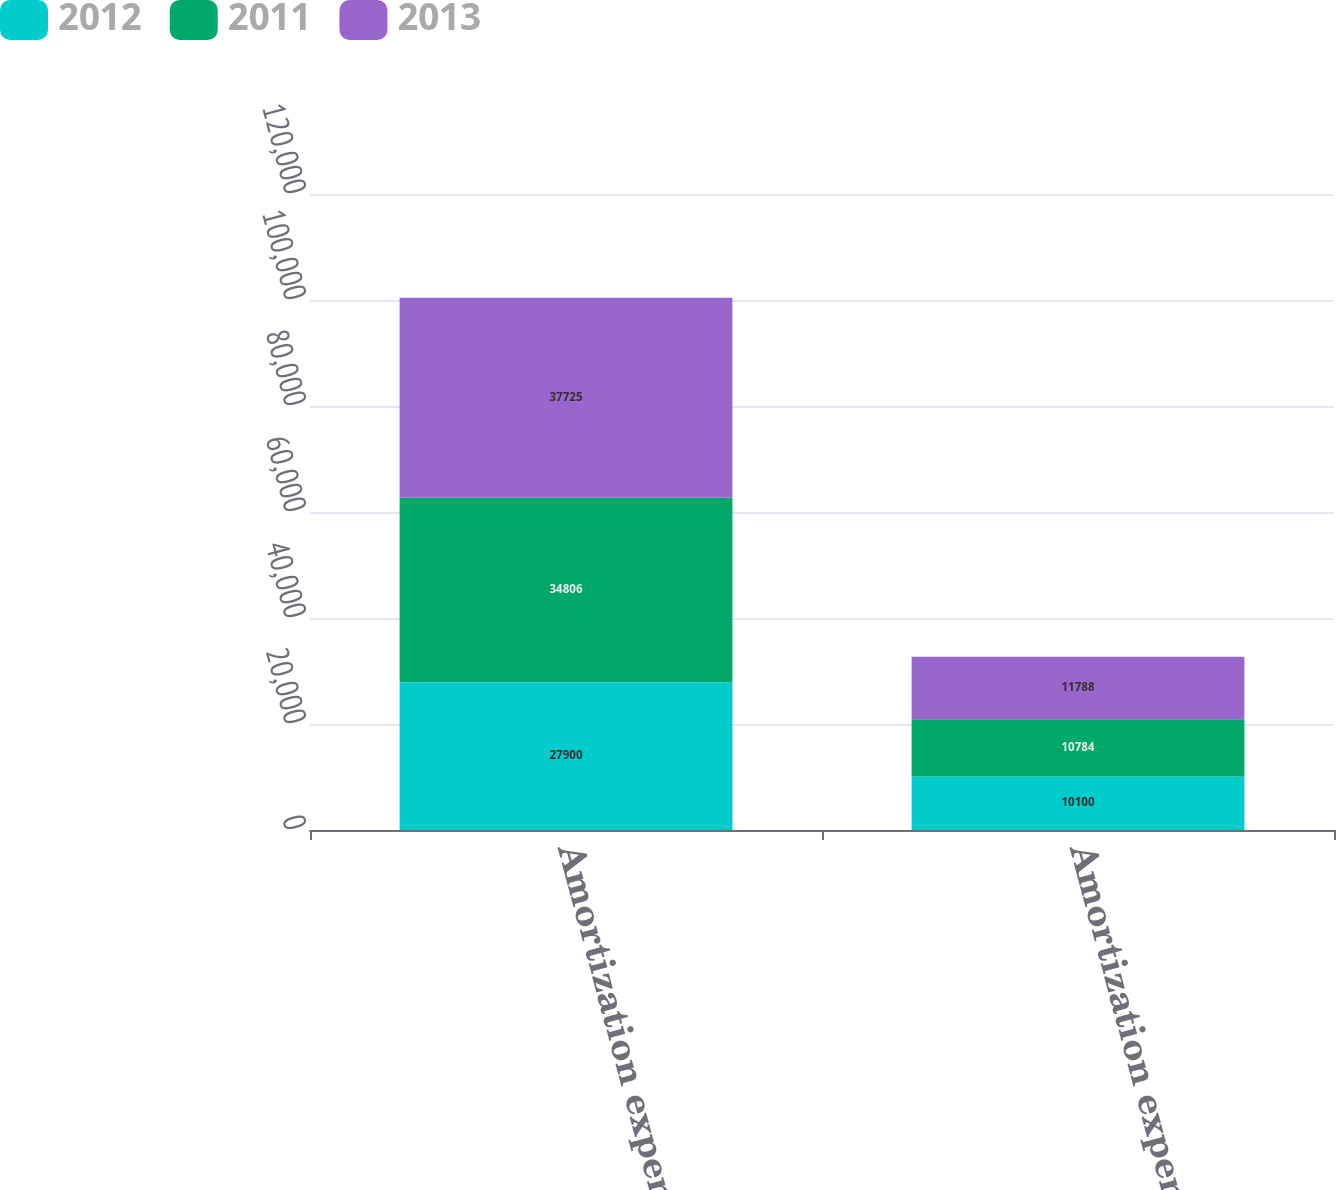<chart> <loc_0><loc_0><loc_500><loc_500><stacked_bar_chart><ecel><fcel>Amortization expense included<fcel>Amortization expense<nl><fcel>2012<fcel>27900<fcel>10100<nl><fcel>2011<fcel>34806<fcel>10784<nl><fcel>2013<fcel>37725<fcel>11788<nl></chart> 